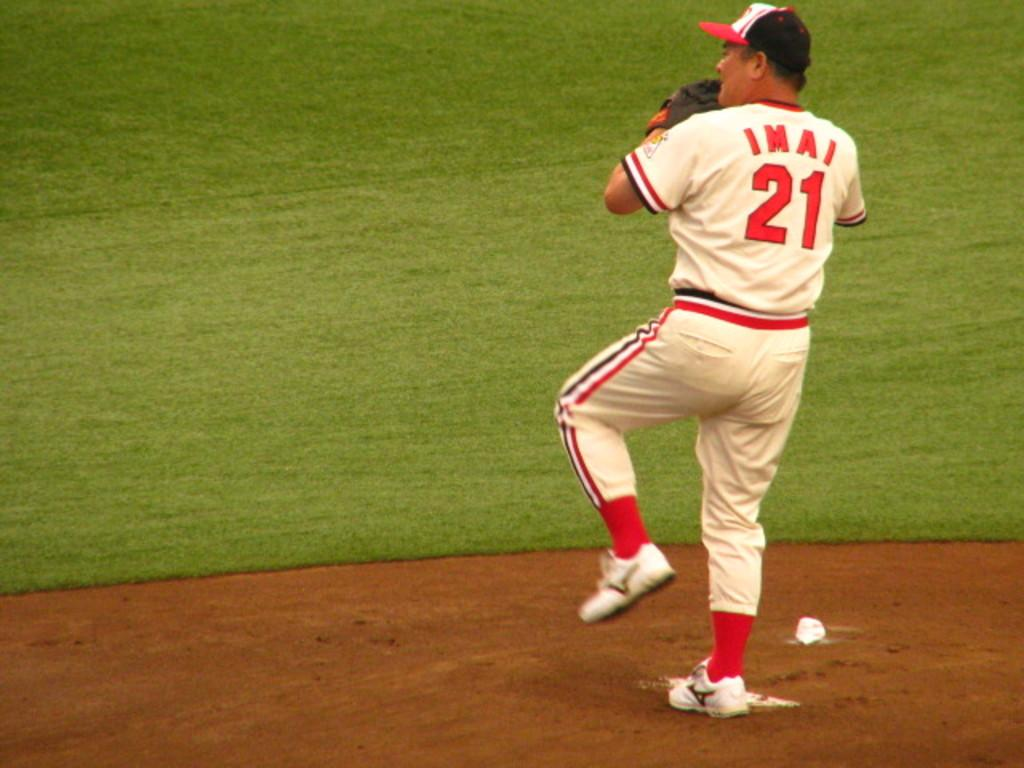Who or what is in the image? There is a person in the image. What is the person doing in the image? The person is standing on the ground and has lifted one leg upwards. What is the ground made of in the image? There is a lot of grass in front of the person, suggesting that the ground is grassy. How does the person stop the balloon from floating away in the image? There is no balloon present in the image, so the person is not stopping a balloon from floating away. 